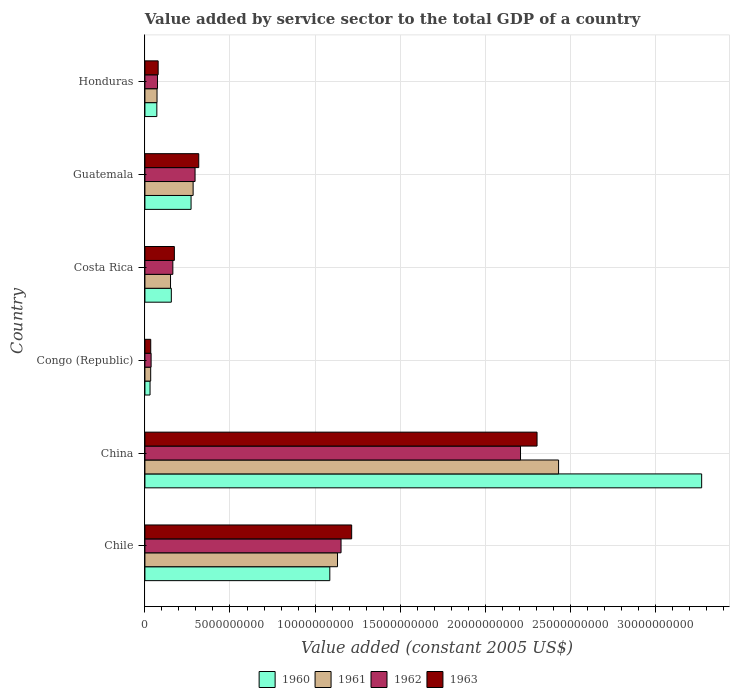How many groups of bars are there?
Provide a short and direct response. 6. How many bars are there on the 2nd tick from the bottom?
Offer a very short reply. 4. In how many cases, is the number of bars for a given country not equal to the number of legend labels?
Your answer should be compact. 0. What is the value added by service sector in 1963 in Guatemala?
Ensure brevity in your answer.  3.16e+09. Across all countries, what is the maximum value added by service sector in 1961?
Offer a very short reply. 2.43e+1. Across all countries, what is the minimum value added by service sector in 1961?
Provide a succinct answer. 3.39e+08. In which country was the value added by service sector in 1962 minimum?
Offer a terse response. Congo (Republic). What is the total value added by service sector in 1962 in the graph?
Offer a terse response. 3.93e+1. What is the difference between the value added by service sector in 1961 in Guatemala and that in Honduras?
Keep it short and to the point. 2.12e+09. What is the difference between the value added by service sector in 1960 in Guatemala and the value added by service sector in 1962 in Honduras?
Make the answer very short. 1.97e+09. What is the average value added by service sector in 1961 per country?
Your response must be concise. 6.84e+09. What is the difference between the value added by service sector in 1962 and value added by service sector in 1963 in Honduras?
Give a very brief answer. -3.72e+07. In how many countries, is the value added by service sector in 1962 greater than 16000000000 US$?
Offer a terse response. 1. What is the ratio of the value added by service sector in 1960 in China to that in Congo (Republic)?
Offer a very short reply. 108.51. Is the value added by service sector in 1962 in Congo (Republic) less than that in Honduras?
Your answer should be very brief. Yes. Is the difference between the value added by service sector in 1962 in Chile and China greater than the difference between the value added by service sector in 1963 in Chile and China?
Ensure brevity in your answer.  Yes. What is the difference between the highest and the second highest value added by service sector in 1960?
Your response must be concise. 2.19e+1. What is the difference between the highest and the lowest value added by service sector in 1961?
Your response must be concise. 2.40e+1. What does the 4th bar from the top in Honduras represents?
Provide a short and direct response. 1960. What does the 2nd bar from the bottom in Congo (Republic) represents?
Make the answer very short. 1961. Is it the case that in every country, the sum of the value added by service sector in 1961 and value added by service sector in 1962 is greater than the value added by service sector in 1960?
Give a very brief answer. Yes. Are all the bars in the graph horizontal?
Ensure brevity in your answer.  Yes. How many countries are there in the graph?
Your answer should be very brief. 6. What is the difference between two consecutive major ticks on the X-axis?
Make the answer very short. 5.00e+09. Are the values on the major ticks of X-axis written in scientific E-notation?
Your answer should be compact. No. Does the graph contain any zero values?
Provide a short and direct response. No. Does the graph contain grids?
Offer a very short reply. Yes. How many legend labels are there?
Offer a terse response. 4. What is the title of the graph?
Offer a terse response. Value added by service sector to the total GDP of a country. Does "2009" appear as one of the legend labels in the graph?
Your answer should be compact. No. What is the label or title of the X-axis?
Offer a very short reply. Value added (constant 2005 US$). What is the label or title of the Y-axis?
Ensure brevity in your answer.  Country. What is the Value added (constant 2005 US$) of 1960 in Chile?
Your response must be concise. 1.09e+1. What is the Value added (constant 2005 US$) in 1961 in Chile?
Your answer should be very brief. 1.13e+1. What is the Value added (constant 2005 US$) in 1962 in Chile?
Your answer should be compact. 1.15e+1. What is the Value added (constant 2005 US$) in 1963 in Chile?
Ensure brevity in your answer.  1.22e+1. What is the Value added (constant 2005 US$) of 1960 in China?
Your response must be concise. 3.27e+1. What is the Value added (constant 2005 US$) of 1961 in China?
Keep it short and to the point. 2.43e+1. What is the Value added (constant 2005 US$) in 1962 in China?
Make the answer very short. 2.21e+1. What is the Value added (constant 2005 US$) in 1963 in China?
Offer a terse response. 2.30e+1. What is the Value added (constant 2005 US$) in 1960 in Congo (Republic)?
Keep it short and to the point. 3.02e+08. What is the Value added (constant 2005 US$) in 1961 in Congo (Republic)?
Your answer should be compact. 3.39e+08. What is the Value added (constant 2005 US$) in 1962 in Congo (Republic)?
Offer a terse response. 3.64e+08. What is the Value added (constant 2005 US$) of 1963 in Congo (Republic)?
Ensure brevity in your answer.  3.42e+08. What is the Value added (constant 2005 US$) of 1960 in Costa Rica?
Provide a short and direct response. 1.55e+09. What is the Value added (constant 2005 US$) in 1961 in Costa Rica?
Your response must be concise. 1.51e+09. What is the Value added (constant 2005 US$) of 1962 in Costa Rica?
Your answer should be very brief. 1.64e+09. What is the Value added (constant 2005 US$) of 1963 in Costa Rica?
Ensure brevity in your answer.  1.73e+09. What is the Value added (constant 2005 US$) of 1960 in Guatemala?
Give a very brief answer. 2.71e+09. What is the Value added (constant 2005 US$) of 1961 in Guatemala?
Provide a succinct answer. 2.83e+09. What is the Value added (constant 2005 US$) in 1962 in Guatemala?
Your answer should be compact. 2.95e+09. What is the Value added (constant 2005 US$) of 1963 in Guatemala?
Make the answer very short. 3.16e+09. What is the Value added (constant 2005 US$) of 1960 in Honduras?
Keep it short and to the point. 7.01e+08. What is the Value added (constant 2005 US$) of 1961 in Honduras?
Your response must be concise. 7.12e+08. What is the Value added (constant 2005 US$) of 1962 in Honduras?
Keep it short and to the point. 7.41e+08. What is the Value added (constant 2005 US$) of 1963 in Honduras?
Give a very brief answer. 7.78e+08. Across all countries, what is the maximum Value added (constant 2005 US$) of 1960?
Your answer should be compact. 3.27e+1. Across all countries, what is the maximum Value added (constant 2005 US$) of 1961?
Provide a short and direct response. 2.43e+1. Across all countries, what is the maximum Value added (constant 2005 US$) of 1962?
Your response must be concise. 2.21e+1. Across all countries, what is the maximum Value added (constant 2005 US$) in 1963?
Ensure brevity in your answer.  2.30e+1. Across all countries, what is the minimum Value added (constant 2005 US$) in 1960?
Your answer should be compact. 3.02e+08. Across all countries, what is the minimum Value added (constant 2005 US$) in 1961?
Provide a short and direct response. 3.39e+08. Across all countries, what is the minimum Value added (constant 2005 US$) in 1962?
Provide a short and direct response. 3.64e+08. Across all countries, what is the minimum Value added (constant 2005 US$) of 1963?
Ensure brevity in your answer.  3.42e+08. What is the total Value added (constant 2005 US$) of 1960 in the graph?
Offer a terse response. 4.89e+1. What is the total Value added (constant 2005 US$) of 1961 in the graph?
Your answer should be very brief. 4.10e+1. What is the total Value added (constant 2005 US$) in 1962 in the graph?
Your response must be concise. 3.93e+1. What is the total Value added (constant 2005 US$) of 1963 in the graph?
Keep it short and to the point. 4.12e+1. What is the difference between the Value added (constant 2005 US$) in 1960 in Chile and that in China?
Provide a succinct answer. -2.19e+1. What is the difference between the Value added (constant 2005 US$) in 1961 in Chile and that in China?
Keep it short and to the point. -1.30e+1. What is the difference between the Value added (constant 2005 US$) of 1962 in Chile and that in China?
Keep it short and to the point. -1.05e+1. What is the difference between the Value added (constant 2005 US$) in 1963 in Chile and that in China?
Your answer should be very brief. -1.09e+1. What is the difference between the Value added (constant 2005 US$) of 1960 in Chile and that in Congo (Republic)?
Your response must be concise. 1.06e+1. What is the difference between the Value added (constant 2005 US$) in 1961 in Chile and that in Congo (Republic)?
Give a very brief answer. 1.10e+1. What is the difference between the Value added (constant 2005 US$) in 1962 in Chile and that in Congo (Republic)?
Offer a terse response. 1.12e+1. What is the difference between the Value added (constant 2005 US$) in 1963 in Chile and that in Congo (Republic)?
Your answer should be compact. 1.18e+1. What is the difference between the Value added (constant 2005 US$) of 1960 in Chile and that in Costa Rica?
Keep it short and to the point. 9.31e+09. What is the difference between the Value added (constant 2005 US$) in 1961 in Chile and that in Costa Rica?
Your answer should be compact. 9.81e+09. What is the difference between the Value added (constant 2005 US$) in 1962 in Chile and that in Costa Rica?
Your answer should be very brief. 9.89e+09. What is the difference between the Value added (constant 2005 US$) of 1963 in Chile and that in Costa Rica?
Keep it short and to the point. 1.04e+1. What is the difference between the Value added (constant 2005 US$) of 1960 in Chile and that in Guatemala?
Offer a very short reply. 8.16e+09. What is the difference between the Value added (constant 2005 US$) of 1961 in Chile and that in Guatemala?
Give a very brief answer. 8.49e+09. What is the difference between the Value added (constant 2005 US$) in 1962 in Chile and that in Guatemala?
Make the answer very short. 8.58e+09. What is the difference between the Value added (constant 2005 US$) of 1963 in Chile and that in Guatemala?
Keep it short and to the point. 8.99e+09. What is the difference between the Value added (constant 2005 US$) of 1960 in Chile and that in Honduras?
Provide a short and direct response. 1.02e+1. What is the difference between the Value added (constant 2005 US$) of 1961 in Chile and that in Honduras?
Your answer should be compact. 1.06e+1. What is the difference between the Value added (constant 2005 US$) in 1962 in Chile and that in Honduras?
Your answer should be compact. 1.08e+1. What is the difference between the Value added (constant 2005 US$) in 1963 in Chile and that in Honduras?
Your answer should be very brief. 1.14e+1. What is the difference between the Value added (constant 2005 US$) in 1960 in China and that in Congo (Republic)?
Your answer should be compact. 3.24e+1. What is the difference between the Value added (constant 2005 US$) of 1961 in China and that in Congo (Republic)?
Give a very brief answer. 2.40e+1. What is the difference between the Value added (constant 2005 US$) in 1962 in China and that in Congo (Republic)?
Give a very brief answer. 2.17e+1. What is the difference between the Value added (constant 2005 US$) of 1963 in China and that in Congo (Republic)?
Ensure brevity in your answer.  2.27e+1. What is the difference between the Value added (constant 2005 US$) of 1960 in China and that in Costa Rica?
Give a very brief answer. 3.12e+1. What is the difference between the Value added (constant 2005 US$) of 1961 in China and that in Costa Rica?
Your answer should be compact. 2.28e+1. What is the difference between the Value added (constant 2005 US$) in 1962 in China and that in Costa Rica?
Offer a terse response. 2.04e+1. What is the difference between the Value added (constant 2005 US$) in 1963 in China and that in Costa Rica?
Give a very brief answer. 2.13e+1. What is the difference between the Value added (constant 2005 US$) in 1960 in China and that in Guatemala?
Give a very brief answer. 3.00e+1. What is the difference between the Value added (constant 2005 US$) of 1961 in China and that in Guatemala?
Provide a short and direct response. 2.15e+1. What is the difference between the Value added (constant 2005 US$) in 1962 in China and that in Guatemala?
Give a very brief answer. 1.91e+1. What is the difference between the Value added (constant 2005 US$) in 1963 in China and that in Guatemala?
Make the answer very short. 1.99e+1. What is the difference between the Value added (constant 2005 US$) of 1960 in China and that in Honduras?
Offer a terse response. 3.20e+1. What is the difference between the Value added (constant 2005 US$) in 1961 in China and that in Honduras?
Your answer should be very brief. 2.36e+1. What is the difference between the Value added (constant 2005 US$) of 1962 in China and that in Honduras?
Give a very brief answer. 2.13e+1. What is the difference between the Value added (constant 2005 US$) of 1963 in China and that in Honduras?
Offer a very short reply. 2.23e+1. What is the difference between the Value added (constant 2005 US$) of 1960 in Congo (Republic) and that in Costa Rica?
Your response must be concise. -1.25e+09. What is the difference between the Value added (constant 2005 US$) of 1961 in Congo (Republic) and that in Costa Rica?
Your answer should be compact. -1.17e+09. What is the difference between the Value added (constant 2005 US$) in 1962 in Congo (Republic) and that in Costa Rica?
Make the answer very short. -1.28e+09. What is the difference between the Value added (constant 2005 US$) in 1963 in Congo (Republic) and that in Costa Rica?
Offer a very short reply. -1.39e+09. What is the difference between the Value added (constant 2005 US$) of 1960 in Congo (Republic) and that in Guatemala?
Offer a very short reply. -2.41e+09. What is the difference between the Value added (constant 2005 US$) of 1961 in Congo (Republic) and that in Guatemala?
Provide a succinct answer. -2.49e+09. What is the difference between the Value added (constant 2005 US$) in 1962 in Congo (Republic) and that in Guatemala?
Ensure brevity in your answer.  -2.58e+09. What is the difference between the Value added (constant 2005 US$) of 1963 in Congo (Republic) and that in Guatemala?
Provide a succinct answer. -2.82e+09. What is the difference between the Value added (constant 2005 US$) in 1960 in Congo (Republic) and that in Honduras?
Provide a short and direct response. -4.00e+08. What is the difference between the Value added (constant 2005 US$) of 1961 in Congo (Republic) and that in Honduras?
Provide a succinct answer. -3.73e+08. What is the difference between the Value added (constant 2005 US$) in 1962 in Congo (Republic) and that in Honduras?
Give a very brief answer. -3.77e+08. What is the difference between the Value added (constant 2005 US$) of 1963 in Congo (Republic) and that in Honduras?
Give a very brief answer. -4.36e+08. What is the difference between the Value added (constant 2005 US$) of 1960 in Costa Rica and that in Guatemala?
Give a very brief answer. -1.16e+09. What is the difference between the Value added (constant 2005 US$) in 1961 in Costa Rica and that in Guatemala?
Ensure brevity in your answer.  -1.33e+09. What is the difference between the Value added (constant 2005 US$) in 1962 in Costa Rica and that in Guatemala?
Offer a very short reply. -1.31e+09. What is the difference between the Value added (constant 2005 US$) of 1963 in Costa Rica and that in Guatemala?
Provide a succinct answer. -1.43e+09. What is the difference between the Value added (constant 2005 US$) in 1960 in Costa Rica and that in Honduras?
Provide a succinct answer. 8.51e+08. What is the difference between the Value added (constant 2005 US$) in 1961 in Costa Rica and that in Honduras?
Your response must be concise. 7.94e+08. What is the difference between the Value added (constant 2005 US$) of 1962 in Costa Rica and that in Honduras?
Your response must be concise. 9.01e+08. What is the difference between the Value added (constant 2005 US$) in 1963 in Costa Rica and that in Honduras?
Provide a succinct answer. 9.53e+08. What is the difference between the Value added (constant 2005 US$) of 1960 in Guatemala and that in Honduras?
Make the answer very short. 2.01e+09. What is the difference between the Value added (constant 2005 US$) of 1961 in Guatemala and that in Honduras?
Your answer should be compact. 2.12e+09. What is the difference between the Value added (constant 2005 US$) of 1962 in Guatemala and that in Honduras?
Offer a terse response. 2.21e+09. What is the difference between the Value added (constant 2005 US$) of 1963 in Guatemala and that in Honduras?
Your response must be concise. 2.39e+09. What is the difference between the Value added (constant 2005 US$) of 1960 in Chile and the Value added (constant 2005 US$) of 1961 in China?
Your answer should be compact. -1.34e+1. What is the difference between the Value added (constant 2005 US$) of 1960 in Chile and the Value added (constant 2005 US$) of 1962 in China?
Ensure brevity in your answer.  -1.12e+1. What is the difference between the Value added (constant 2005 US$) of 1960 in Chile and the Value added (constant 2005 US$) of 1963 in China?
Make the answer very short. -1.22e+1. What is the difference between the Value added (constant 2005 US$) in 1961 in Chile and the Value added (constant 2005 US$) in 1962 in China?
Provide a succinct answer. -1.08e+1. What is the difference between the Value added (constant 2005 US$) of 1961 in Chile and the Value added (constant 2005 US$) of 1963 in China?
Offer a terse response. -1.17e+1. What is the difference between the Value added (constant 2005 US$) of 1962 in Chile and the Value added (constant 2005 US$) of 1963 in China?
Ensure brevity in your answer.  -1.15e+1. What is the difference between the Value added (constant 2005 US$) in 1960 in Chile and the Value added (constant 2005 US$) in 1961 in Congo (Republic)?
Offer a very short reply. 1.05e+1. What is the difference between the Value added (constant 2005 US$) in 1960 in Chile and the Value added (constant 2005 US$) in 1962 in Congo (Republic)?
Offer a very short reply. 1.05e+1. What is the difference between the Value added (constant 2005 US$) of 1960 in Chile and the Value added (constant 2005 US$) of 1963 in Congo (Republic)?
Offer a terse response. 1.05e+1. What is the difference between the Value added (constant 2005 US$) of 1961 in Chile and the Value added (constant 2005 US$) of 1962 in Congo (Republic)?
Offer a very short reply. 1.10e+1. What is the difference between the Value added (constant 2005 US$) of 1961 in Chile and the Value added (constant 2005 US$) of 1963 in Congo (Republic)?
Provide a short and direct response. 1.10e+1. What is the difference between the Value added (constant 2005 US$) in 1962 in Chile and the Value added (constant 2005 US$) in 1963 in Congo (Republic)?
Ensure brevity in your answer.  1.12e+1. What is the difference between the Value added (constant 2005 US$) of 1960 in Chile and the Value added (constant 2005 US$) of 1961 in Costa Rica?
Your answer should be very brief. 9.36e+09. What is the difference between the Value added (constant 2005 US$) in 1960 in Chile and the Value added (constant 2005 US$) in 1962 in Costa Rica?
Give a very brief answer. 9.23e+09. What is the difference between the Value added (constant 2005 US$) of 1960 in Chile and the Value added (constant 2005 US$) of 1963 in Costa Rica?
Your response must be concise. 9.14e+09. What is the difference between the Value added (constant 2005 US$) of 1961 in Chile and the Value added (constant 2005 US$) of 1962 in Costa Rica?
Offer a very short reply. 9.68e+09. What is the difference between the Value added (constant 2005 US$) in 1961 in Chile and the Value added (constant 2005 US$) in 1963 in Costa Rica?
Your response must be concise. 9.59e+09. What is the difference between the Value added (constant 2005 US$) of 1962 in Chile and the Value added (constant 2005 US$) of 1963 in Costa Rica?
Your answer should be compact. 9.80e+09. What is the difference between the Value added (constant 2005 US$) in 1960 in Chile and the Value added (constant 2005 US$) in 1961 in Guatemala?
Ensure brevity in your answer.  8.03e+09. What is the difference between the Value added (constant 2005 US$) in 1960 in Chile and the Value added (constant 2005 US$) in 1962 in Guatemala?
Keep it short and to the point. 7.92e+09. What is the difference between the Value added (constant 2005 US$) in 1960 in Chile and the Value added (constant 2005 US$) in 1963 in Guatemala?
Provide a succinct answer. 7.70e+09. What is the difference between the Value added (constant 2005 US$) in 1961 in Chile and the Value added (constant 2005 US$) in 1962 in Guatemala?
Your response must be concise. 8.37e+09. What is the difference between the Value added (constant 2005 US$) in 1961 in Chile and the Value added (constant 2005 US$) in 1963 in Guatemala?
Ensure brevity in your answer.  8.16e+09. What is the difference between the Value added (constant 2005 US$) in 1962 in Chile and the Value added (constant 2005 US$) in 1963 in Guatemala?
Offer a terse response. 8.36e+09. What is the difference between the Value added (constant 2005 US$) of 1960 in Chile and the Value added (constant 2005 US$) of 1961 in Honduras?
Make the answer very short. 1.02e+1. What is the difference between the Value added (constant 2005 US$) of 1960 in Chile and the Value added (constant 2005 US$) of 1962 in Honduras?
Ensure brevity in your answer.  1.01e+1. What is the difference between the Value added (constant 2005 US$) of 1960 in Chile and the Value added (constant 2005 US$) of 1963 in Honduras?
Offer a terse response. 1.01e+1. What is the difference between the Value added (constant 2005 US$) of 1961 in Chile and the Value added (constant 2005 US$) of 1962 in Honduras?
Offer a very short reply. 1.06e+1. What is the difference between the Value added (constant 2005 US$) of 1961 in Chile and the Value added (constant 2005 US$) of 1963 in Honduras?
Give a very brief answer. 1.05e+1. What is the difference between the Value added (constant 2005 US$) in 1962 in Chile and the Value added (constant 2005 US$) in 1963 in Honduras?
Provide a short and direct response. 1.07e+1. What is the difference between the Value added (constant 2005 US$) in 1960 in China and the Value added (constant 2005 US$) in 1961 in Congo (Republic)?
Offer a terse response. 3.24e+1. What is the difference between the Value added (constant 2005 US$) in 1960 in China and the Value added (constant 2005 US$) in 1962 in Congo (Republic)?
Keep it short and to the point. 3.24e+1. What is the difference between the Value added (constant 2005 US$) in 1960 in China and the Value added (constant 2005 US$) in 1963 in Congo (Republic)?
Your answer should be very brief. 3.24e+1. What is the difference between the Value added (constant 2005 US$) in 1961 in China and the Value added (constant 2005 US$) in 1962 in Congo (Republic)?
Ensure brevity in your answer.  2.39e+1. What is the difference between the Value added (constant 2005 US$) of 1961 in China and the Value added (constant 2005 US$) of 1963 in Congo (Republic)?
Ensure brevity in your answer.  2.40e+1. What is the difference between the Value added (constant 2005 US$) of 1962 in China and the Value added (constant 2005 US$) of 1963 in Congo (Republic)?
Provide a short and direct response. 2.17e+1. What is the difference between the Value added (constant 2005 US$) in 1960 in China and the Value added (constant 2005 US$) in 1961 in Costa Rica?
Offer a terse response. 3.12e+1. What is the difference between the Value added (constant 2005 US$) of 1960 in China and the Value added (constant 2005 US$) of 1962 in Costa Rica?
Provide a succinct answer. 3.11e+1. What is the difference between the Value added (constant 2005 US$) of 1960 in China and the Value added (constant 2005 US$) of 1963 in Costa Rica?
Give a very brief answer. 3.10e+1. What is the difference between the Value added (constant 2005 US$) of 1961 in China and the Value added (constant 2005 US$) of 1962 in Costa Rica?
Keep it short and to the point. 2.27e+1. What is the difference between the Value added (constant 2005 US$) of 1961 in China and the Value added (constant 2005 US$) of 1963 in Costa Rica?
Make the answer very short. 2.26e+1. What is the difference between the Value added (constant 2005 US$) of 1962 in China and the Value added (constant 2005 US$) of 1963 in Costa Rica?
Keep it short and to the point. 2.03e+1. What is the difference between the Value added (constant 2005 US$) of 1960 in China and the Value added (constant 2005 US$) of 1961 in Guatemala?
Provide a short and direct response. 2.99e+1. What is the difference between the Value added (constant 2005 US$) of 1960 in China and the Value added (constant 2005 US$) of 1962 in Guatemala?
Make the answer very short. 2.98e+1. What is the difference between the Value added (constant 2005 US$) in 1960 in China and the Value added (constant 2005 US$) in 1963 in Guatemala?
Your answer should be compact. 2.96e+1. What is the difference between the Value added (constant 2005 US$) in 1961 in China and the Value added (constant 2005 US$) in 1962 in Guatemala?
Give a very brief answer. 2.14e+1. What is the difference between the Value added (constant 2005 US$) in 1961 in China and the Value added (constant 2005 US$) in 1963 in Guatemala?
Keep it short and to the point. 2.11e+1. What is the difference between the Value added (constant 2005 US$) of 1962 in China and the Value added (constant 2005 US$) of 1963 in Guatemala?
Ensure brevity in your answer.  1.89e+1. What is the difference between the Value added (constant 2005 US$) of 1960 in China and the Value added (constant 2005 US$) of 1961 in Honduras?
Ensure brevity in your answer.  3.20e+1. What is the difference between the Value added (constant 2005 US$) of 1960 in China and the Value added (constant 2005 US$) of 1962 in Honduras?
Your response must be concise. 3.20e+1. What is the difference between the Value added (constant 2005 US$) of 1960 in China and the Value added (constant 2005 US$) of 1963 in Honduras?
Offer a terse response. 3.19e+1. What is the difference between the Value added (constant 2005 US$) of 1961 in China and the Value added (constant 2005 US$) of 1962 in Honduras?
Ensure brevity in your answer.  2.36e+1. What is the difference between the Value added (constant 2005 US$) of 1961 in China and the Value added (constant 2005 US$) of 1963 in Honduras?
Your answer should be compact. 2.35e+1. What is the difference between the Value added (constant 2005 US$) of 1962 in China and the Value added (constant 2005 US$) of 1963 in Honduras?
Your answer should be very brief. 2.13e+1. What is the difference between the Value added (constant 2005 US$) in 1960 in Congo (Republic) and the Value added (constant 2005 US$) in 1961 in Costa Rica?
Provide a short and direct response. -1.20e+09. What is the difference between the Value added (constant 2005 US$) of 1960 in Congo (Republic) and the Value added (constant 2005 US$) of 1962 in Costa Rica?
Offer a terse response. -1.34e+09. What is the difference between the Value added (constant 2005 US$) in 1960 in Congo (Republic) and the Value added (constant 2005 US$) in 1963 in Costa Rica?
Your response must be concise. -1.43e+09. What is the difference between the Value added (constant 2005 US$) in 1961 in Congo (Republic) and the Value added (constant 2005 US$) in 1962 in Costa Rica?
Give a very brief answer. -1.30e+09. What is the difference between the Value added (constant 2005 US$) of 1961 in Congo (Republic) and the Value added (constant 2005 US$) of 1963 in Costa Rica?
Give a very brief answer. -1.39e+09. What is the difference between the Value added (constant 2005 US$) in 1962 in Congo (Republic) and the Value added (constant 2005 US$) in 1963 in Costa Rica?
Offer a very short reply. -1.37e+09. What is the difference between the Value added (constant 2005 US$) of 1960 in Congo (Republic) and the Value added (constant 2005 US$) of 1961 in Guatemala?
Offer a terse response. -2.53e+09. What is the difference between the Value added (constant 2005 US$) in 1960 in Congo (Republic) and the Value added (constant 2005 US$) in 1962 in Guatemala?
Offer a very short reply. -2.65e+09. What is the difference between the Value added (constant 2005 US$) of 1960 in Congo (Republic) and the Value added (constant 2005 US$) of 1963 in Guatemala?
Ensure brevity in your answer.  -2.86e+09. What is the difference between the Value added (constant 2005 US$) of 1961 in Congo (Republic) and the Value added (constant 2005 US$) of 1962 in Guatemala?
Your answer should be very brief. -2.61e+09. What is the difference between the Value added (constant 2005 US$) of 1961 in Congo (Republic) and the Value added (constant 2005 US$) of 1963 in Guatemala?
Provide a succinct answer. -2.83e+09. What is the difference between the Value added (constant 2005 US$) of 1962 in Congo (Republic) and the Value added (constant 2005 US$) of 1963 in Guatemala?
Ensure brevity in your answer.  -2.80e+09. What is the difference between the Value added (constant 2005 US$) in 1960 in Congo (Republic) and the Value added (constant 2005 US$) in 1961 in Honduras?
Give a very brief answer. -4.10e+08. What is the difference between the Value added (constant 2005 US$) of 1960 in Congo (Republic) and the Value added (constant 2005 US$) of 1962 in Honduras?
Offer a very short reply. -4.39e+08. What is the difference between the Value added (constant 2005 US$) in 1960 in Congo (Republic) and the Value added (constant 2005 US$) in 1963 in Honduras?
Keep it short and to the point. -4.76e+08. What is the difference between the Value added (constant 2005 US$) of 1961 in Congo (Republic) and the Value added (constant 2005 US$) of 1962 in Honduras?
Your answer should be very brief. -4.02e+08. What is the difference between the Value added (constant 2005 US$) of 1961 in Congo (Republic) and the Value added (constant 2005 US$) of 1963 in Honduras?
Provide a succinct answer. -4.39e+08. What is the difference between the Value added (constant 2005 US$) in 1962 in Congo (Republic) and the Value added (constant 2005 US$) in 1963 in Honduras?
Make the answer very short. -4.14e+08. What is the difference between the Value added (constant 2005 US$) of 1960 in Costa Rica and the Value added (constant 2005 US$) of 1961 in Guatemala?
Make the answer very short. -1.28e+09. What is the difference between the Value added (constant 2005 US$) of 1960 in Costa Rica and the Value added (constant 2005 US$) of 1962 in Guatemala?
Your response must be concise. -1.39e+09. What is the difference between the Value added (constant 2005 US$) in 1960 in Costa Rica and the Value added (constant 2005 US$) in 1963 in Guatemala?
Provide a short and direct response. -1.61e+09. What is the difference between the Value added (constant 2005 US$) in 1961 in Costa Rica and the Value added (constant 2005 US$) in 1962 in Guatemala?
Provide a short and direct response. -1.44e+09. What is the difference between the Value added (constant 2005 US$) of 1961 in Costa Rica and the Value added (constant 2005 US$) of 1963 in Guatemala?
Provide a short and direct response. -1.66e+09. What is the difference between the Value added (constant 2005 US$) of 1962 in Costa Rica and the Value added (constant 2005 US$) of 1963 in Guatemala?
Make the answer very short. -1.52e+09. What is the difference between the Value added (constant 2005 US$) in 1960 in Costa Rica and the Value added (constant 2005 US$) in 1961 in Honduras?
Your answer should be very brief. 8.41e+08. What is the difference between the Value added (constant 2005 US$) of 1960 in Costa Rica and the Value added (constant 2005 US$) of 1962 in Honduras?
Your answer should be very brief. 8.12e+08. What is the difference between the Value added (constant 2005 US$) of 1960 in Costa Rica and the Value added (constant 2005 US$) of 1963 in Honduras?
Ensure brevity in your answer.  7.75e+08. What is the difference between the Value added (constant 2005 US$) in 1961 in Costa Rica and the Value added (constant 2005 US$) in 1962 in Honduras?
Give a very brief answer. 7.65e+08. What is the difference between the Value added (constant 2005 US$) in 1961 in Costa Rica and the Value added (constant 2005 US$) in 1963 in Honduras?
Provide a succinct answer. 7.28e+08. What is the difference between the Value added (constant 2005 US$) of 1962 in Costa Rica and the Value added (constant 2005 US$) of 1963 in Honduras?
Ensure brevity in your answer.  8.63e+08. What is the difference between the Value added (constant 2005 US$) of 1960 in Guatemala and the Value added (constant 2005 US$) of 1961 in Honduras?
Offer a terse response. 2.00e+09. What is the difference between the Value added (constant 2005 US$) in 1960 in Guatemala and the Value added (constant 2005 US$) in 1962 in Honduras?
Your response must be concise. 1.97e+09. What is the difference between the Value added (constant 2005 US$) of 1960 in Guatemala and the Value added (constant 2005 US$) of 1963 in Honduras?
Your answer should be compact. 1.93e+09. What is the difference between the Value added (constant 2005 US$) of 1961 in Guatemala and the Value added (constant 2005 US$) of 1962 in Honduras?
Provide a succinct answer. 2.09e+09. What is the difference between the Value added (constant 2005 US$) of 1961 in Guatemala and the Value added (constant 2005 US$) of 1963 in Honduras?
Provide a succinct answer. 2.06e+09. What is the difference between the Value added (constant 2005 US$) of 1962 in Guatemala and the Value added (constant 2005 US$) of 1963 in Honduras?
Your answer should be compact. 2.17e+09. What is the average Value added (constant 2005 US$) in 1960 per country?
Give a very brief answer. 8.14e+09. What is the average Value added (constant 2005 US$) of 1961 per country?
Your response must be concise. 6.84e+09. What is the average Value added (constant 2005 US$) in 1962 per country?
Provide a short and direct response. 6.55e+09. What is the average Value added (constant 2005 US$) of 1963 per country?
Your answer should be compact. 6.87e+09. What is the difference between the Value added (constant 2005 US$) of 1960 and Value added (constant 2005 US$) of 1961 in Chile?
Provide a short and direct response. -4.53e+08. What is the difference between the Value added (constant 2005 US$) of 1960 and Value added (constant 2005 US$) of 1962 in Chile?
Make the answer very short. -6.60e+08. What is the difference between the Value added (constant 2005 US$) in 1960 and Value added (constant 2005 US$) in 1963 in Chile?
Provide a succinct answer. -1.29e+09. What is the difference between the Value added (constant 2005 US$) of 1961 and Value added (constant 2005 US$) of 1962 in Chile?
Your answer should be very brief. -2.07e+08. What is the difference between the Value added (constant 2005 US$) in 1961 and Value added (constant 2005 US$) in 1963 in Chile?
Ensure brevity in your answer.  -8.32e+08. What is the difference between the Value added (constant 2005 US$) of 1962 and Value added (constant 2005 US$) of 1963 in Chile?
Provide a short and direct response. -6.25e+08. What is the difference between the Value added (constant 2005 US$) of 1960 and Value added (constant 2005 US$) of 1961 in China?
Ensure brevity in your answer.  8.41e+09. What is the difference between the Value added (constant 2005 US$) of 1960 and Value added (constant 2005 US$) of 1962 in China?
Offer a terse response. 1.06e+1. What is the difference between the Value added (constant 2005 US$) in 1960 and Value added (constant 2005 US$) in 1963 in China?
Give a very brief answer. 9.68e+09. What is the difference between the Value added (constant 2005 US$) of 1961 and Value added (constant 2005 US$) of 1962 in China?
Your answer should be compact. 2.24e+09. What is the difference between the Value added (constant 2005 US$) in 1961 and Value added (constant 2005 US$) in 1963 in China?
Your answer should be compact. 1.27e+09. What is the difference between the Value added (constant 2005 US$) of 1962 and Value added (constant 2005 US$) of 1963 in China?
Your answer should be compact. -9.71e+08. What is the difference between the Value added (constant 2005 US$) in 1960 and Value added (constant 2005 US$) in 1961 in Congo (Republic)?
Give a very brief answer. -3.74e+07. What is the difference between the Value added (constant 2005 US$) in 1960 and Value added (constant 2005 US$) in 1962 in Congo (Republic)?
Ensure brevity in your answer.  -6.23e+07. What is the difference between the Value added (constant 2005 US$) of 1960 and Value added (constant 2005 US$) of 1963 in Congo (Republic)?
Provide a short and direct response. -4.05e+07. What is the difference between the Value added (constant 2005 US$) in 1961 and Value added (constant 2005 US$) in 1962 in Congo (Republic)?
Your answer should be compact. -2.49e+07. What is the difference between the Value added (constant 2005 US$) of 1961 and Value added (constant 2005 US$) of 1963 in Congo (Republic)?
Make the answer very short. -3.09e+06. What is the difference between the Value added (constant 2005 US$) in 1962 and Value added (constant 2005 US$) in 1963 in Congo (Republic)?
Your answer should be very brief. 2.18e+07. What is the difference between the Value added (constant 2005 US$) in 1960 and Value added (constant 2005 US$) in 1961 in Costa Rica?
Offer a terse response. 4.72e+07. What is the difference between the Value added (constant 2005 US$) in 1960 and Value added (constant 2005 US$) in 1962 in Costa Rica?
Make the answer very short. -8.87e+07. What is the difference between the Value added (constant 2005 US$) of 1960 and Value added (constant 2005 US$) of 1963 in Costa Rica?
Keep it short and to the point. -1.78e+08. What is the difference between the Value added (constant 2005 US$) of 1961 and Value added (constant 2005 US$) of 1962 in Costa Rica?
Provide a succinct answer. -1.36e+08. What is the difference between the Value added (constant 2005 US$) in 1961 and Value added (constant 2005 US$) in 1963 in Costa Rica?
Provide a short and direct response. -2.25e+08. What is the difference between the Value added (constant 2005 US$) in 1962 and Value added (constant 2005 US$) in 1963 in Costa Rica?
Make the answer very short. -8.94e+07. What is the difference between the Value added (constant 2005 US$) in 1960 and Value added (constant 2005 US$) in 1961 in Guatemala?
Ensure brevity in your answer.  -1.22e+08. What is the difference between the Value added (constant 2005 US$) of 1960 and Value added (constant 2005 US$) of 1962 in Guatemala?
Offer a very short reply. -2.35e+08. What is the difference between the Value added (constant 2005 US$) of 1960 and Value added (constant 2005 US$) of 1963 in Guatemala?
Provide a short and direct response. -4.53e+08. What is the difference between the Value added (constant 2005 US$) of 1961 and Value added (constant 2005 US$) of 1962 in Guatemala?
Give a very brief answer. -1.14e+08. What is the difference between the Value added (constant 2005 US$) in 1961 and Value added (constant 2005 US$) in 1963 in Guatemala?
Your response must be concise. -3.31e+08. What is the difference between the Value added (constant 2005 US$) in 1962 and Value added (constant 2005 US$) in 1963 in Guatemala?
Your answer should be very brief. -2.17e+08. What is the difference between the Value added (constant 2005 US$) of 1960 and Value added (constant 2005 US$) of 1961 in Honduras?
Offer a terse response. -1.04e+07. What is the difference between the Value added (constant 2005 US$) of 1960 and Value added (constant 2005 US$) of 1962 in Honduras?
Give a very brief answer. -3.93e+07. What is the difference between the Value added (constant 2005 US$) of 1960 and Value added (constant 2005 US$) of 1963 in Honduras?
Make the answer very short. -7.65e+07. What is the difference between the Value added (constant 2005 US$) in 1961 and Value added (constant 2005 US$) in 1962 in Honduras?
Provide a succinct answer. -2.89e+07. What is the difference between the Value added (constant 2005 US$) in 1961 and Value added (constant 2005 US$) in 1963 in Honduras?
Offer a terse response. -6.62e+07. What is the difference between the Value added (constant 2005 US$) in 1962 and Value added (constant 2005 US$) in 1963 in Honduras?
Ensure brevity in your answer.  -3.72e+07. What is the ratio of the Value added (constant 2005 US$) in 1960 in Chile to that in China?
Your response must be concise. 0.33. What is the ratio of the Value added (constant 2005 US$) in 1961 in Chile to that in China?
Your response must be concise. 0.47. What is the ratio of the Value added (constant 2005 US$) of 1962 in Chile to that in China?
Make the answer very short. 0.52. What is the ratio of the Value added (constant 2005 US$) in 1963 in Chile to that in China?
Your answer should be compact. 0.53. What is the ratio of the Value added (constant 2005 US$) in 1960 in Chile to that in Congo (Republic)?
Your answer should be very brief. 36.04. What is the ratio of the Value added (constant 2005 US$) of 1961 in Chile to that in Congo (Republic)?
Ensure brevity in your answer.  33.4. What is the ratio of the Value added (constant 2005 US$) of 1962 in Chile to that in Congo (Republic)?
Make the answer very short. 31.68. What is the ratio of the Value added (constant 2005 US$) in 1963 in Chile to that in Congo (Republic)?
Offer a terse response. 35.53. What is the ratio of the Value added (constant 2005 US$) of 1960 in Chile to that in Costa Rica?
Your answer should be very brief. 7. What is the ratio of the Value added (constant 2005 US$) of 1961 in Chile to that in Costa Rica?
Your answer should be very brief. 7.52. What is the ratio of the Value added (constant 2005 US$) in 1962 in Chile to that in Costa Rica?
Your answer should be very brief. 7.02. What is the ratio of the Value added (constant 2005 US$) in 1963 in Chile to that in Costa Rica?
Make the answer very short. 7.02. What is the ratio of the Value added (constant 2005 US$) in 1960 in Chile to that in Guatemala?
Your response must be concise. 4.01. What is the ratio of the Value added (constant 2005 US$) in 1961 in Chile to that in Guatemala?
Keep it short and to the point. 4. What is the ratio of the Value added (constant 2005 US$) in 1962 in Chile to that in Guatemala?
Keep it short and to the point. 3.91. What is the ratio of the Value added (constant 2005 US$) in 1963 in Chile to that in Guatemala?
Ensure brevity in your answer.  3.84. What is the ratio of the Value added (constant 2005 US$) of 1960 in Chile to that in Honduras?
Your answer should be very brief. 15.5. What is the ratio of the Value added (constant 2005 US$) in 1961 in Chile to that in Honduras?
Ensure brevity in your answer.  15.91. What is the ratio of the Value added (constant 2005 US$) of 1962 in Chile to that in Honduras?
Give a very brief answer. 15.57. What is the ratio of the Value added (constant 2005 US$) of 1963 in Chile to that in Honduras?
Provide a short and direct response. 15.63. What is the ratio of the Value added (constant 2005 US$) of 1960 in China to that in Congo (Republic)?
Give a very brief answer. 108.51. What is the ratio of the Value added (constant 2005 US$) of 1961 in China to that in Congo (Republic)?
Make the answer very short. 71.73. What is the ratio of the Value added (constant 2005 US$) in 1962 in China to that in Congo (Republic)?
Your answer should be compact. 60.67. What is the ratio of the Value added (constant 2005 US$) of 1963 in China to that in Congo (Republic)?
Offer a very short reply. 67.39. What is the ratio of the Value added (constant 2005 US$) of 1960 in China to that in Costa Rica?
Keep it short and to the point. 21.08. What is the ratio of the Value added (constant 2005 US$) of 1961 in China to that in Costa Rica?
Your answer should be very brief. 16.15. What is the ratio of the Value added (constant 2005 US$) of 1962 in China to that in Costa Rica?
Give a very brief answer. 13.45. What is the ratio of the Value added (constant 2005 US$) in 1963 in China to that in Costa Rica?
Make the answer very short. 13.32. What is the ratio of the Value added (constant 2005 US$) in 1960 in China to that in Guatemala?
Provide a succinct answer. 12.07. What is the ratio of the Value added (constant 2005 US$) of 1961 in China to that in Guatemala?
Offer a very short reply. 8.58. What is the ratio of the Value added (constant 2005 US$) of 1962 in China to that in Guatemala?
Your answer should be very brief. 7.49. What is the ratio of the Value added (constant 2005 US$) in 1963 in China to that in Guatemala?
Ensure brevity in your answer.  7.28. What is the ratio of the Value added (constant 2005 US$) in 1960 in China to that in Honduras?
Give a very brief answer. 46.67. What is the ratio of the Value added (constant 2005 US$) of 1961 in China to that in Honduras?
Your response must be concise. 34.17. What is the ratio of the Value added (constant 2005 US$) in 1962 in China to that in Honduras?
Provide a short and direct response. 29.81. What is the ratio of the Value added (constant 2005 US$) in 1963 in China to that in Honduras?
Make the answer very short. 29.63. What is the ratio of the Value added (constant 2005 US$) in 1960 in Congo (Republic) to that in Costa Rica?
Give a very brief answer. 0.19. What is the ratio of the Value added (constant 2005 US$) of 1961 in Congo (Republic) to that in Costa Rica?
Your answer should be very brief. 0.23. What is the ratio of the Value added (constant 2005 US$) of 1962 in Congo (Republic) to that in Costa Rica?
Your answer should be very brief. 0.22. What is the ratio of the Value added (constant 2005 US$) in 1963 in Congo (Republic) to that in Costa Rica?
Your answer should be very brief. 0.2. What is the ratio of the Value added (constant 2005 US$) of 1960 in Congo (Republic) to that in Guatemala?
Provide a succinct answer. 0.11. What is the ratio of the Value added (constant 2005 US$) of 1961 in Congo (Republic) to that in Guatemala?
Your response must be concise. 0.12. What is the ratio of the Value added (constant 2005 US$) of 1962 in Congo (Republic) to that in Guatemala?
Your answer should be very brief. 0.12. What is the ratio of the Value added (constant 2005 US$) of 1963 in Congo (Republic) to that in Guatemala?
Ensure brevity in your answer.  0.11. What is the ratio of the Value added (constant 2005 US$) of 1960 in Congo (Republic) to that in Honduras?
Your response must be concise. 0.43. What is the ratio of the Value added (constant 2005 US$) in 1961 in Congo (Republic) to that in Honduras?
Ensure brevity in your answer.  0.48. What is the ratio of the Value added (constant 2005 US$) in 1962 in Congo (Republic) to that in Honduras?
Provide a succinct answer. 0.49. What is the ratio of the Value added (constant 2005 US$) in 1963 in Congo (Republic) to that in Honduras?
Offer a terse response. 0.44. What is the ratio of the Value added (constant 2005 US$) of 1960 in Costa Rica to that in Guatemala?
Give a very brief answer. 0.57. What is the ratio of the Value added (constant 2005 US$) in 1961 in Costa Rica to that in Guatemala?
Your answer should be compact. 0.53. What is the ratio of the Value added (constant 2005 US$) in 1962 in Costa Rica to that in Guatemala?
Provide a succinct answer. 0.56. What is the ratio of the Value added (constant 2005 US$) of 1963 in Costa Rica to that in Guatemala?
Keep it short and to the point. 0.55. What is the ratio of the Value added (constant 2005 US$) in 1960 in Costa Rica to that in Honduras?
Make the answer very short. 2.21. What is the ratio of the Value added (constant 2005 US$) of 1961 in Costa Rica to that in Honduras?
Make the answer very short. 2.12. What is the ratio of the Value added (constant 2005 US$) in 1962 in Costa Rica to that in Honduras?
Your answer should be very brief. 2.22. What is the ratio of the Value added (constant 2005 US$) of 1963 in Costa Rica to that in Honduras?
Provide a succinct answer. 2.23. What is the ratio of the Value added (constant 2005 US$) in 1960 in Guatemala to that in Honduras?
Your answer should be compact. 3.87. What is the ratio of the Value added (constant 2005 US$) in 1961 in Guatemala to that in Honduras?
Your answer should be very brief. 3.98. What is the ratio of the Value added (constant 2005 US$) in 1962 in Guatemala to that in Honduras?
Make the answer very short. 3.98. What is the ratio of the Value added (constant 2005 US$) in 1963 in Guatemala to that in Honduras?
Offer a very short reply. 4.07. What is the difference between the highest and the second highest Value added (constant 2005 US$) in 1960?
Provide a short and direct response. 2.19e+1. What is the difference between the highest and the second highest Value added (constant 2005 US$) of 1961?
Offer a very short reply. 1.30e+1. What is the difference between the highest and the second highest Value added (constant 2005 US$) in 1962?
Offer a very short reply. 1.05e+1. What is the difference between the highest and the second highest Value added (constant 2005 US$) in 1963?
Your answer should be very brief. 1.09e+1. What is the difference between the highest and the lowest Value added (constant 2005 US$) in 1960?
Provide a short and direct response. 3.24e+1. What is the difference between the highest and the lowest Value added (constant 2005 US$) in 1961?
Give a very brief answer. 2.40e+1. What is the difference between the highest and the lowest Value added (constant 2005 US$) in 1962?
Provide a succinct answer. 2.17e+1. What is the difference between the highest and the lowest Value added (constant 2005 US$) of 1963?
Your answer should be compact. 2.27e+1. 